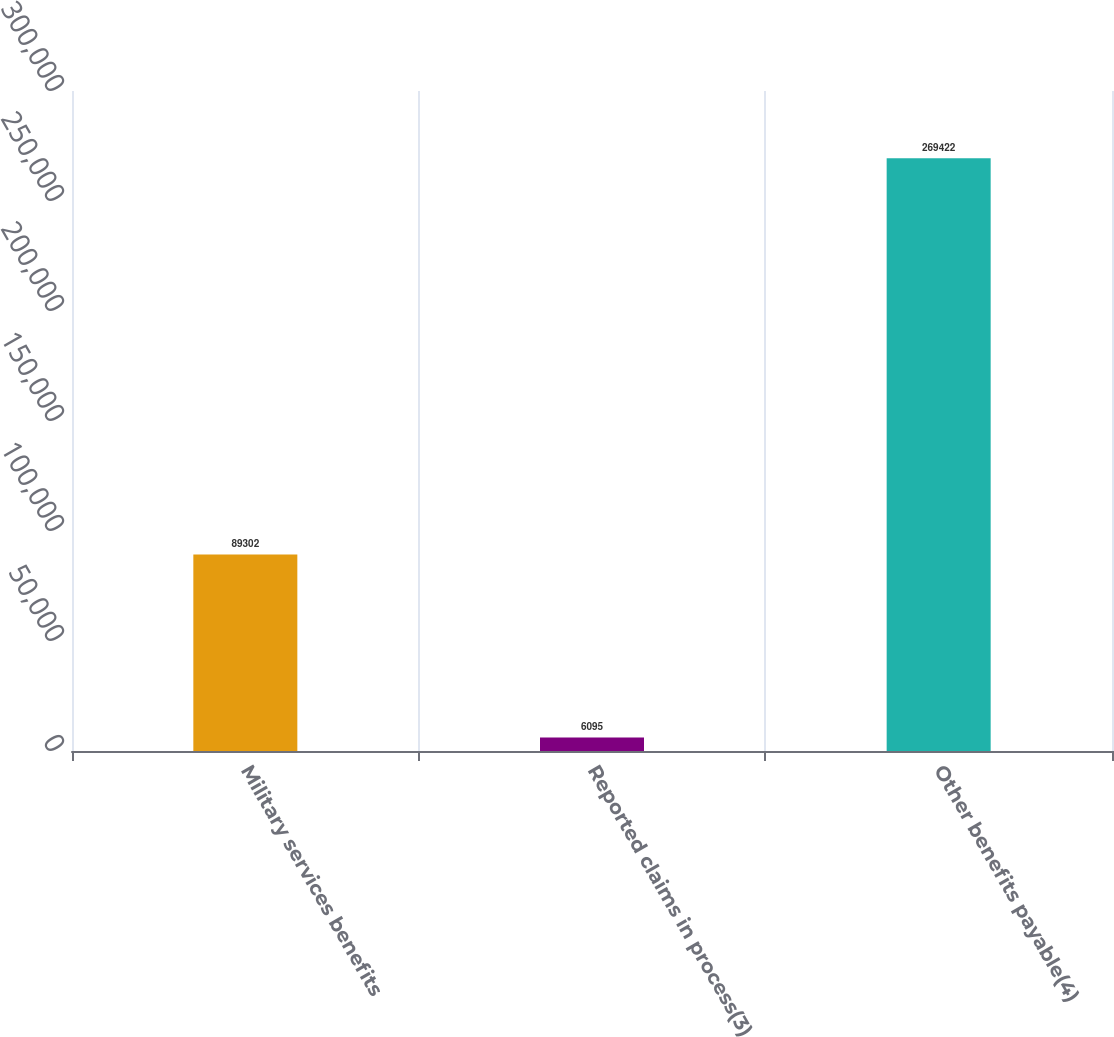<chart> <loc_0><loc_0><loc_500><loc_500><bar_chart><fcel>Military services benefits<fcel>Reported claims in process(3)<fcel>Other benefits payable(4)<nl><fcel>89302<fcel>6095<fcel>269422<nl></chart> 